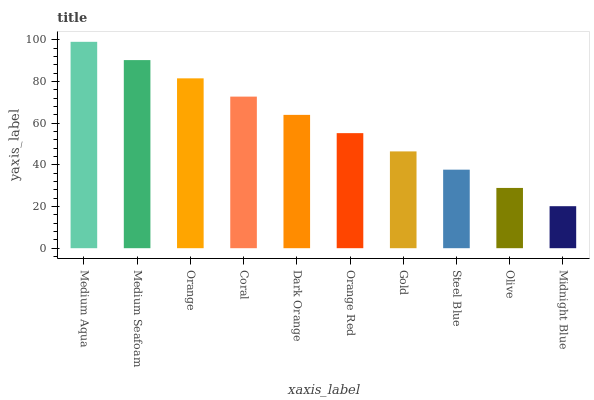Is Midnight Blue the minimum?
Answer yes or no. Yes. Is Medium Aqua the maximum?
Answer yes or no. Yes. Is Medium Seafoam the minimum?
Answer yes or no. No. Is Medium Seafoam the maximum?
Answer yes or no. No. Is Medium Aqua greater than Medium Seafoam?
Answer yes or no. Yes. Is Medium Seafoam less than Medium Aqua?
Answer yes or no. Yes. Is Medium Seafoam greater than Medium Aqua?
Answer yes or no. No. Is Medium Aqua less than Medium Seafoam?
Answer yes or no. No. Is Dark Orange the high median?
Answer yes or no. Yes. Is Orange Red the low median?
Answer yes or no. Yes. Is Midnight Blue the high median?
Answer yes or no. No. Is Coral the low median?
Answer yes or no. No. 